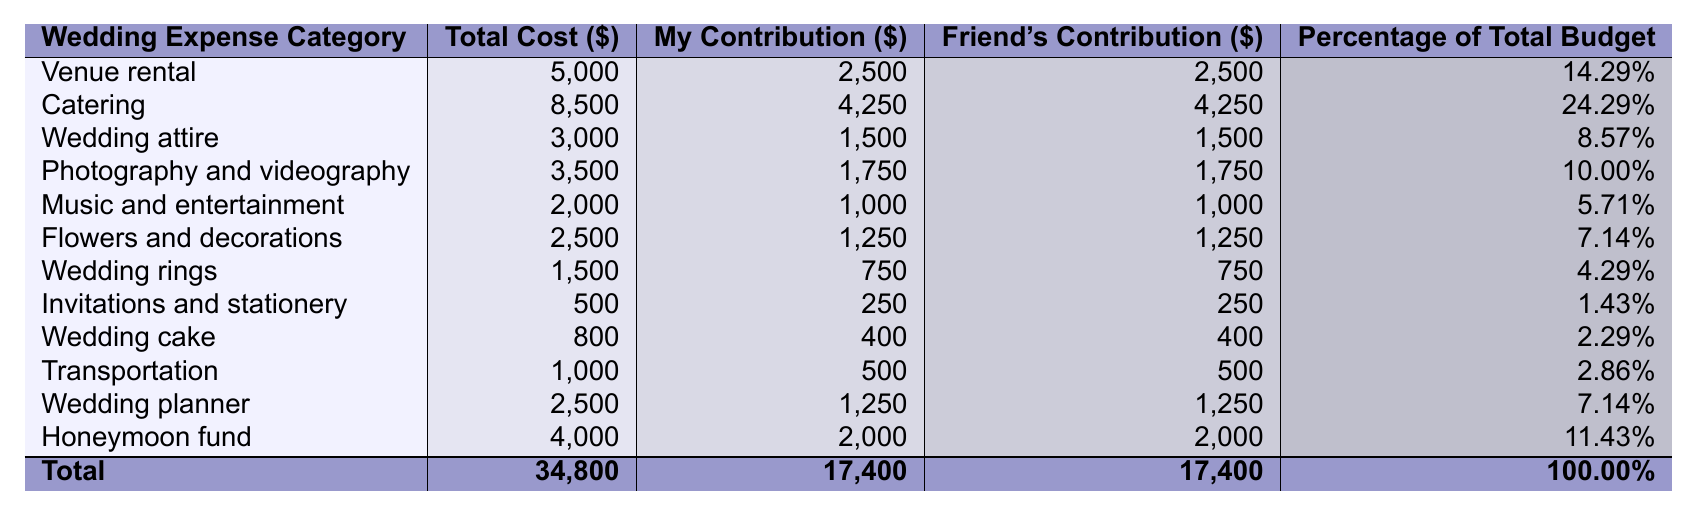What is the total cost of the wedding? The total cost is listed at the bottom of the table in the "Total Cost ($)" column, which shows a value of 34,800.
Answer: 34,800 How much did each of us contribute to the catering expense? Looking at the "Catering" expense row, both contributions are shown in the "My Contribution ($)" and "Friend's Contribution ($)" columns, which both are 4,250.
Answer: 4,250 Which wedding expense category has the highest percentage of the total budget? The "Catering" category has the highest percentage listed in the "Percentage of Total Budget" column with a value of 24.29%.
Answer: Catering What is the total contribution made by both friends alone? To calculate the total contribution, I add "My Contribution ($)" and "Friend's Contribution ($)" for each category, but both are equal, so I can just multiply the total of my contribution (17,400) by 2, giving 34,800.
Answer: 34,800 Is the contribution for the wedding rings equal from both friends? Both contributions for "Wedding rings" as shown in the table are 750 each, confirming they are equal.
Answer: Yes What is the average cost of the wedding expenses? The average cost can be calculated by summing total costs (34,800) and dividing by the number of categories (12), giving 34,800 / 12 = 2,900.
Answer: 2,900 How much more did we spend on photography and videography compared to transportation? The costs are listed at 3,500 for photography and videography and 1,000 for transportation. The difference is 3,500 - 1,000 = 2,500.
Answer: 2,500 Did we contribute equally to the wedding attire expenses? Yes, both contributions for "Wedding attire" are 1,500, showing that the expenses are equal.
Answer: Yes What percentage of the total budget is allocated for flowers and decorations? In the "Flowers and decorations" row, the percentage listed in the "Percentage of Total Budget" column is 7.14%.
Answer: 7.14% What are the combined contributions towards the honeymoon fund? Both contributions toward the "Honeymoon fund" are 2,000 each, summing to 2,000 + 2,000 = 4,000.
Answer: 4,000 